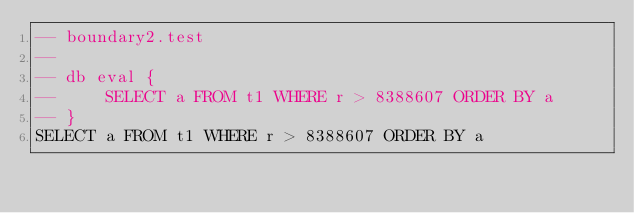<code> <loc_0><loc_0><loc_500><loc_500><_SQL_>-- boundary2.test
-- 
-- db eval {
--     SELECT a FROM t1 WHERE r > 8388607 ORDER BY a
-- }
SELECT a FROM t1 WHERE r > 8388607 ORDER BY a</code> 